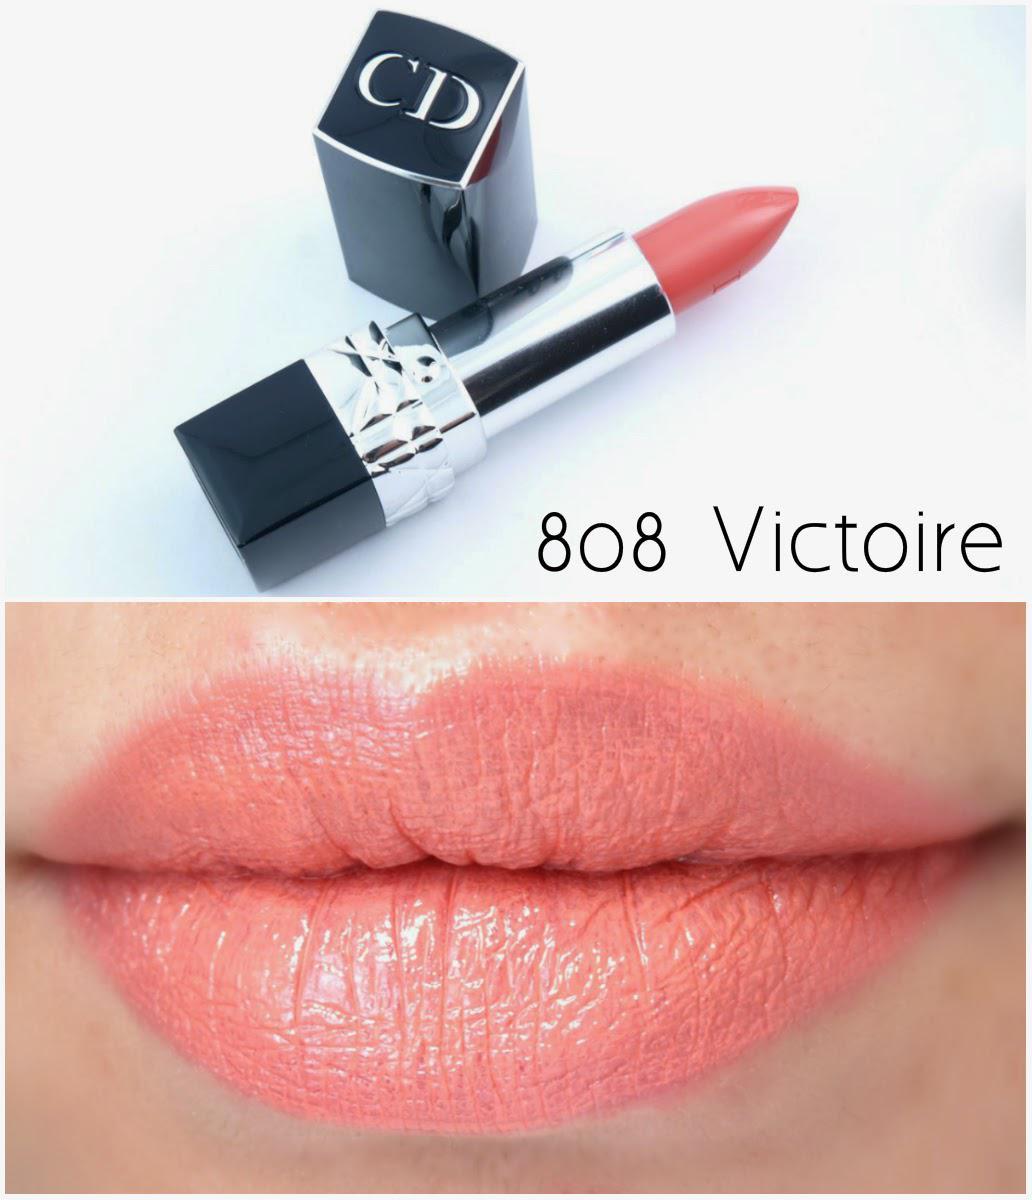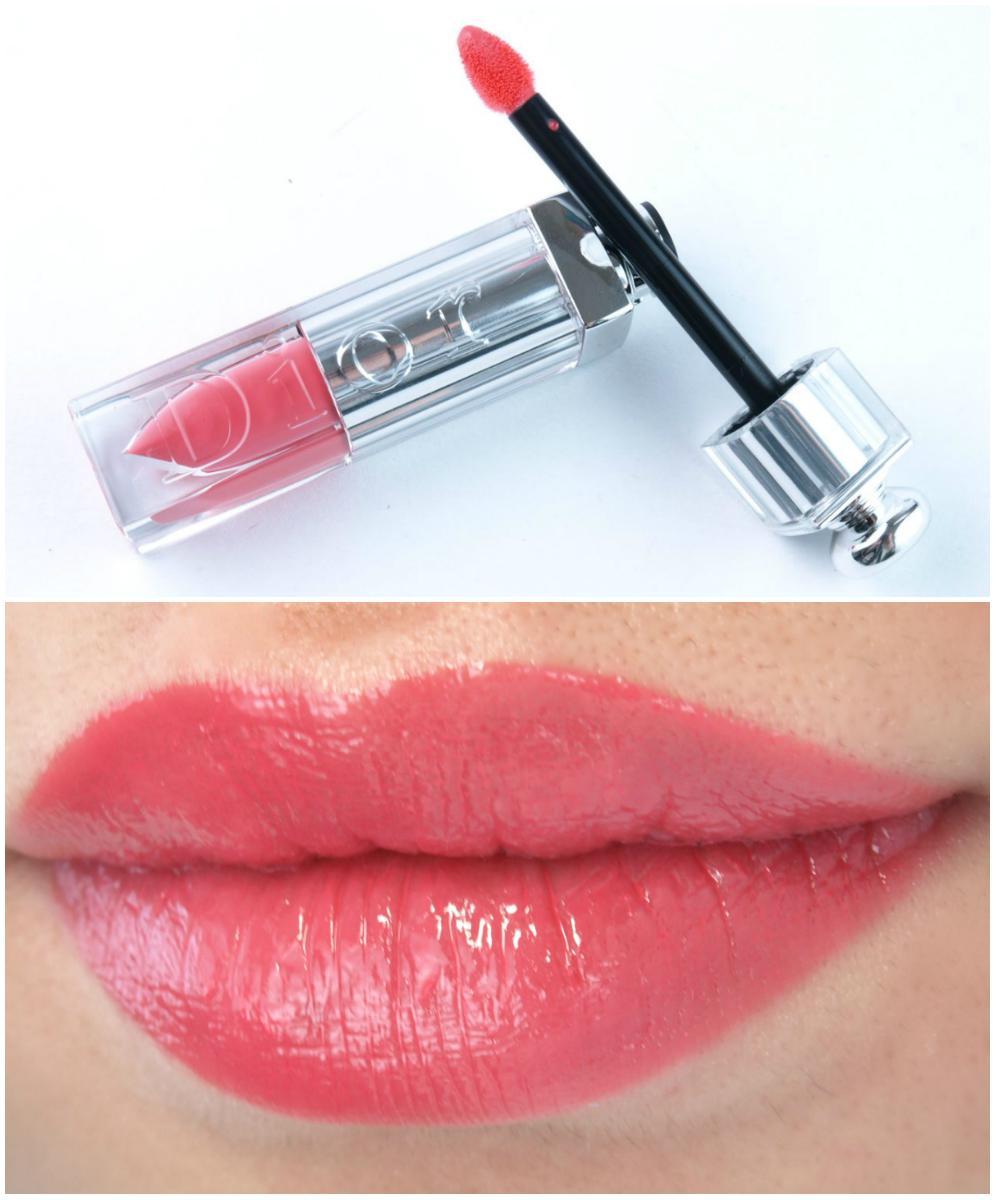The first image is the image on the left, the second image is the image on the right. Evaluate the accuracy of this statement regarding the images: "There are three lipsticks in the image on the left". Is it true? Answer yes or no. No. The first image is the image on the left, the second image is the image on the right. Examine the images to the left and right. Is the description "A pair of lips is shown in each image." accurate? Answer yes or no. Yes. 